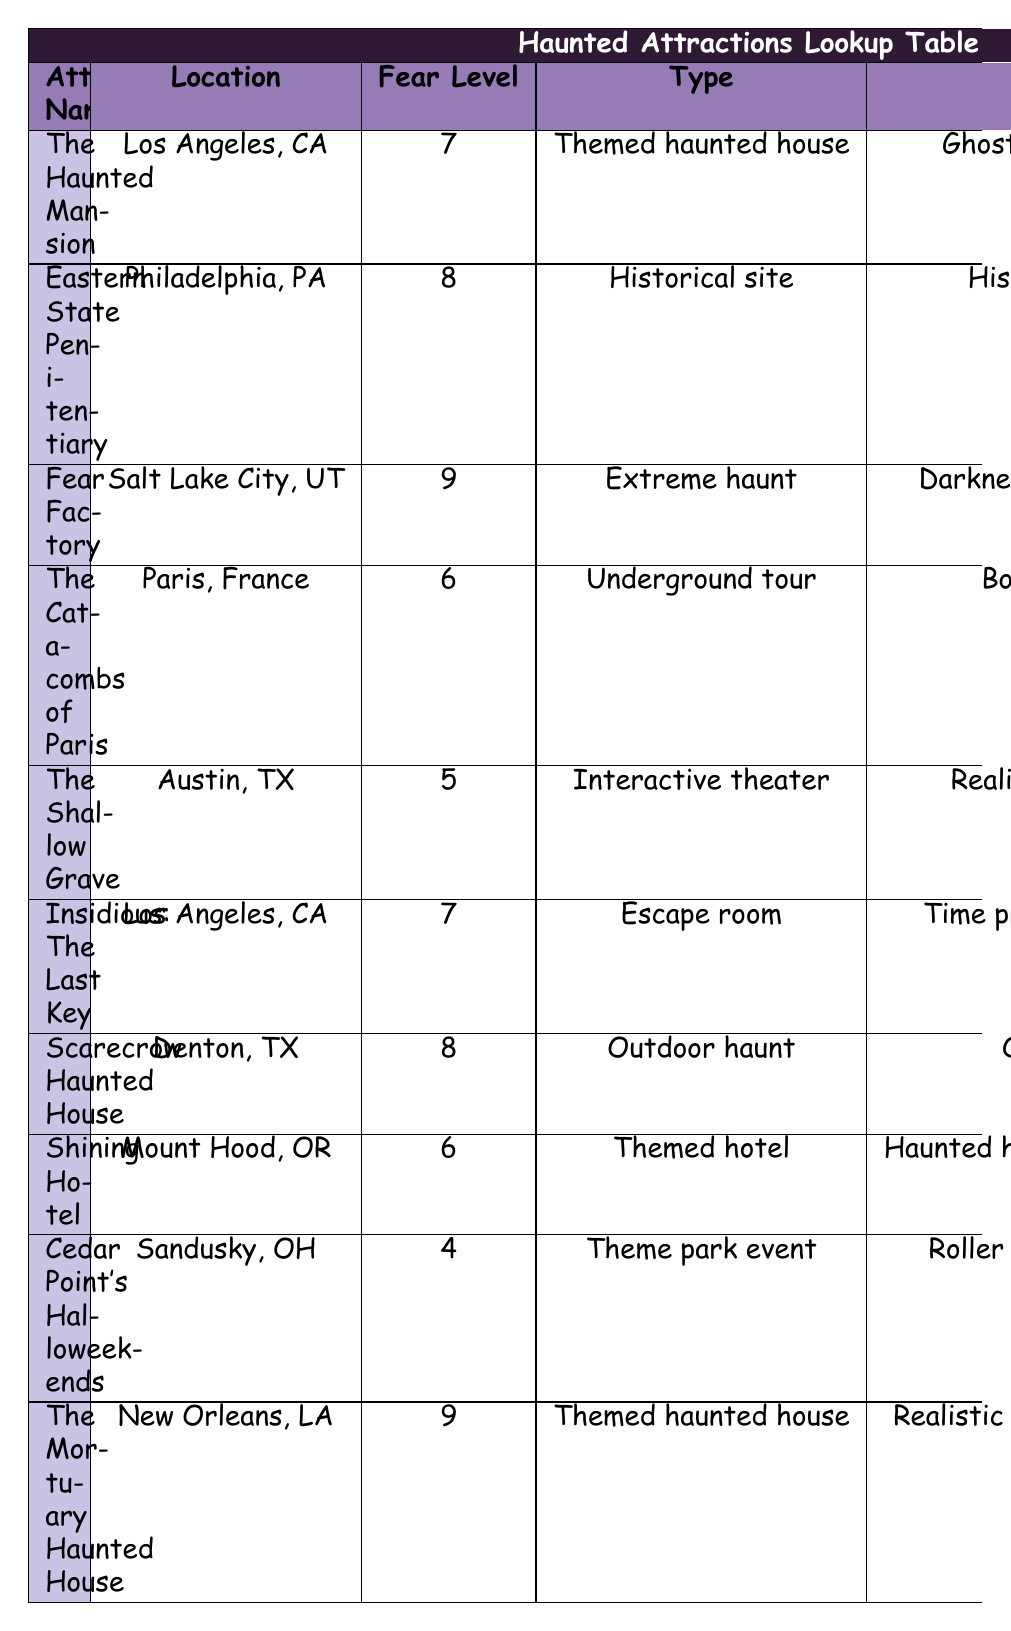What is the fear level of The Haunted Mansion? The fear level for The Haunted Mansion, located in Los Angeles, California, is directly listed in the table under the corresponding column. It is 7.
Answer: 7 Which attraction has the highest fear level? By reviewing the fear levels for all attractions, Fear Factory and The Mortuary Haunted House both have the highest fear levels of 9.
Answer: Fear Factory and The Mortuary Haunted House Is Scarecrow Haunted House located in Texas? The table indicates that Scarecrow Haunted House is located in Denton, Texas. Therefore, the answer is true.
Answer: Yes What are the key scare factors for Eastern State Penitentiary? The key scare factors are listed in the table under Eastern State Penitentiary, which are the historical prison setting, legendary ghost stories, and live actors.
Answer: Historical prison setting, legendary ghost stories, live actors What is the average fear level of attractions in California? The attractions in California listed are The Haunted Mansion (7) and Insidious: The Last Key Escape Room (7). The average is calculated by adding the fear levels and dividing by the number of attractions: (7 + 7) / 2 = 7.
Answer: 7 Does The Shallow Grave have a fear level lower than 6? The fear level of The Shallow Grave is 5, which is indeed lower than 6. Therefore, the answer is true.
Answer: Yes What is the difference in fear level between Cedar Point's Halloweekends and The Catacombs of Paris? Cedar Point's Halloweekends has a fear level of 4, while The Catacombs of Paris has a fear level of 6. The difference is calculated as follows: 6 - 4 = 2.
Answer: 2 Which attraction type has a fear level of 9? The table reveals that both Fear Factory and The Mortuary Haunted House are categorized as themed haunted houses and have a fear level of 9.
Answer: Themed haunted house How many haunted attractions have a fear level of 6 or lower? The attractions with a fear level of 6 or lower are The Catacombs of Paris (6), The Shallow Grave (5), and Cedar Point's Halloweekends (4), totaling 3 attractions.
Answer: 3 